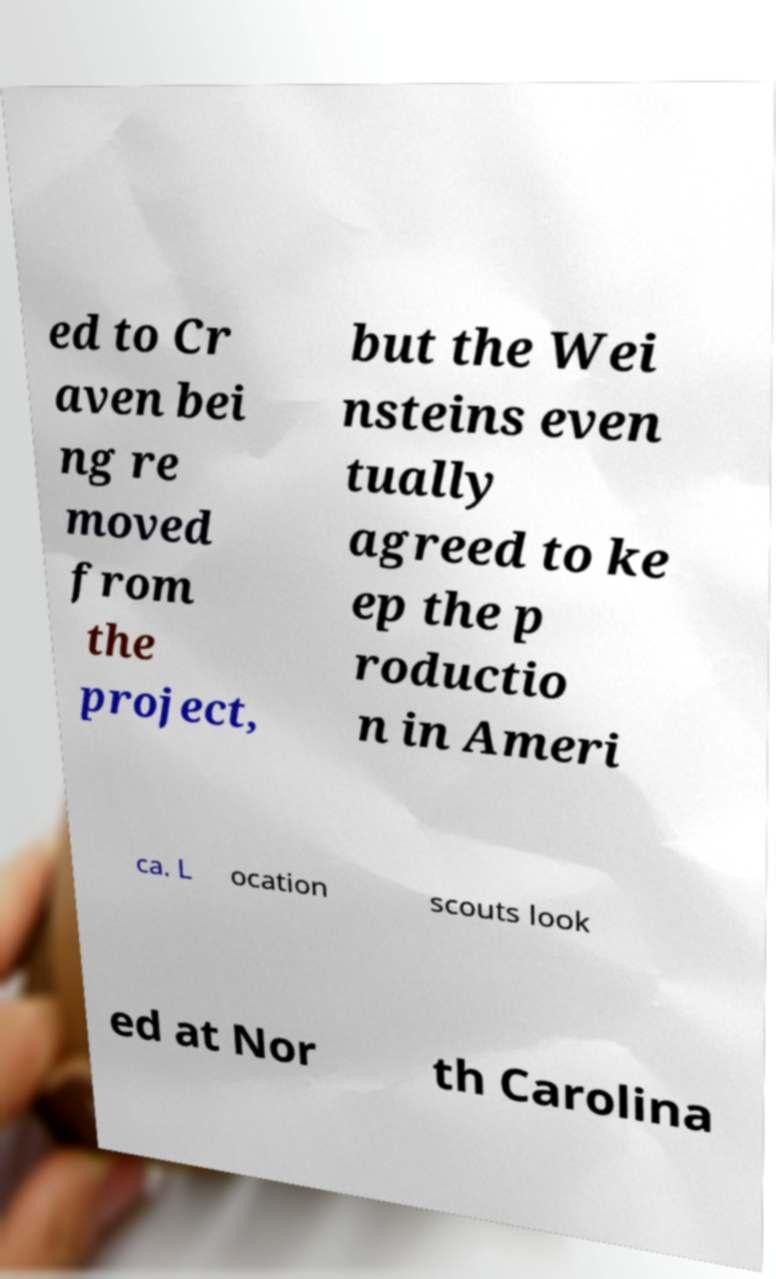Could you assist in decoding the text presented in this image and type it out clearly? ed to Cr aven bei ng re moved from the project, but the Wei nsteins even tually agreed to ke ep the p roductio n in Ameri ca. L ocation scouts look ed at Nor th Carolina 